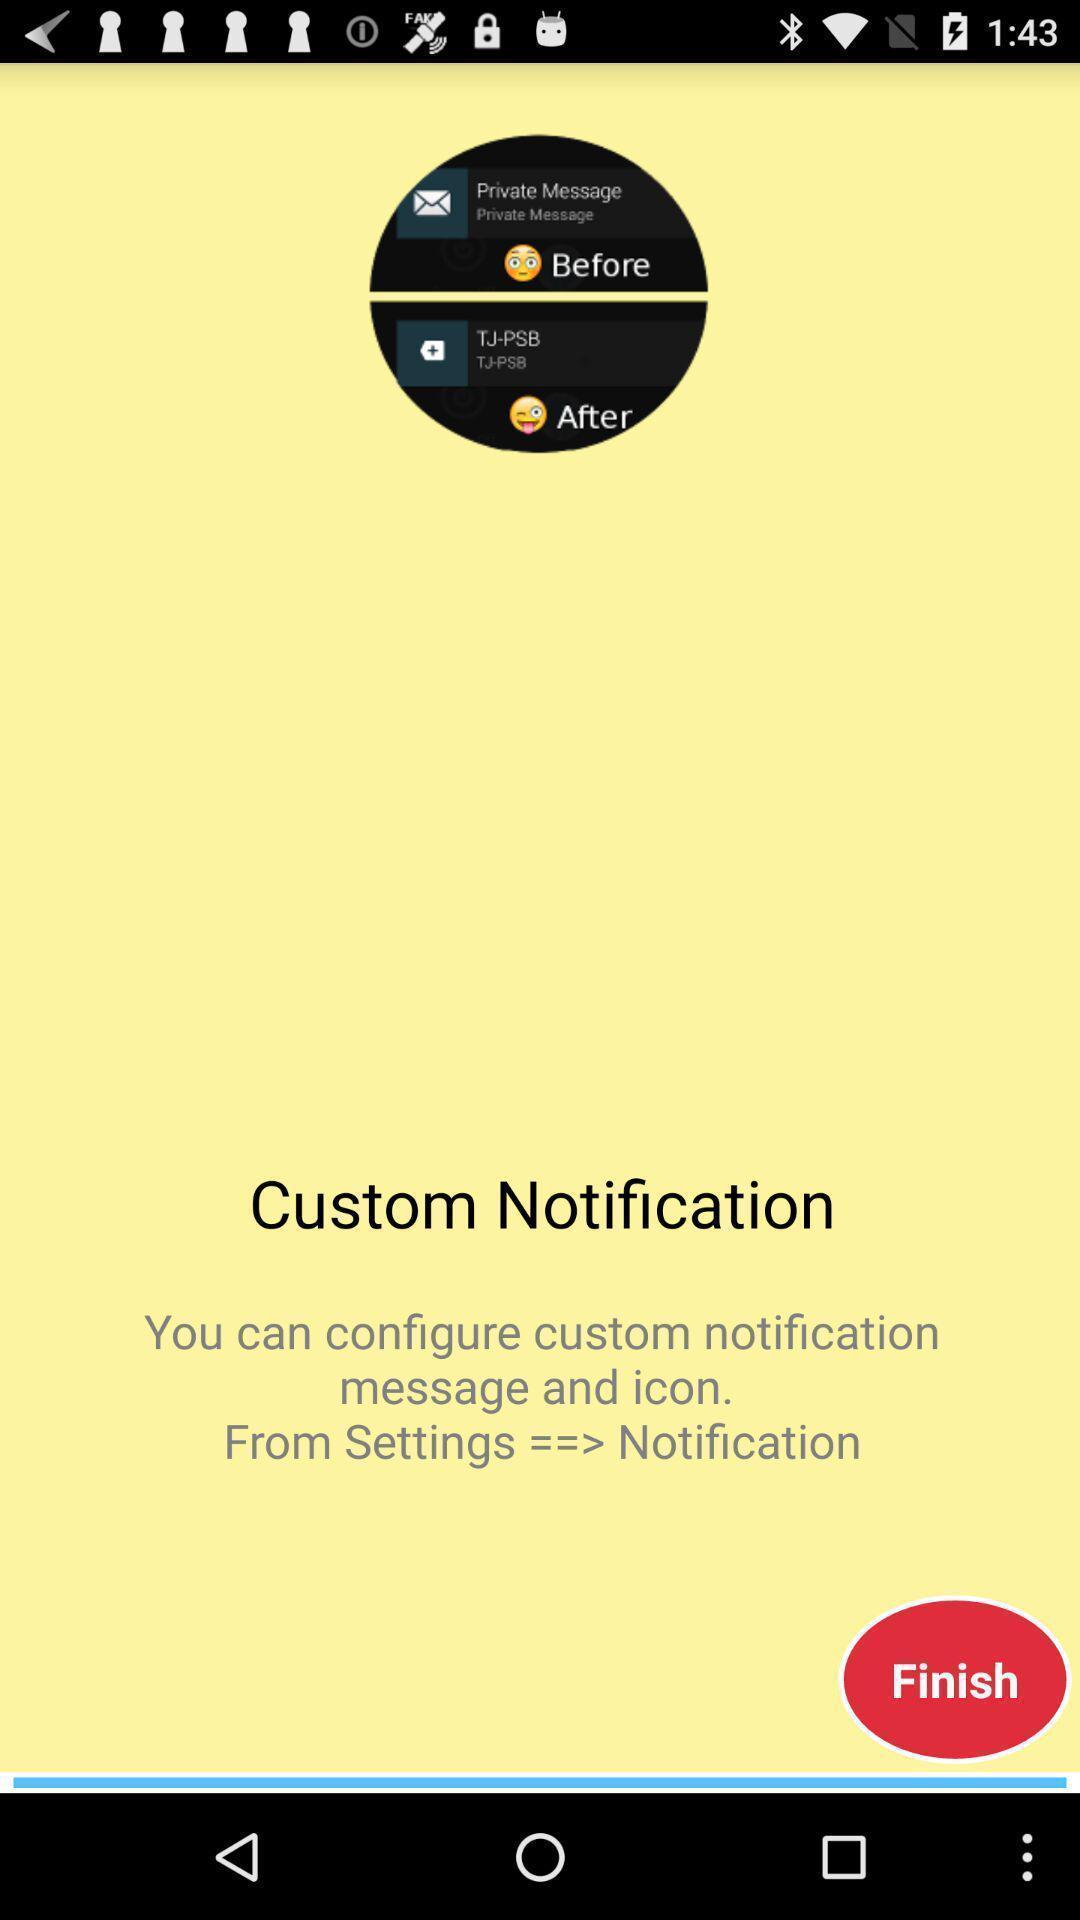What can you discern from this picture? Page displays to configure notifications in app. 